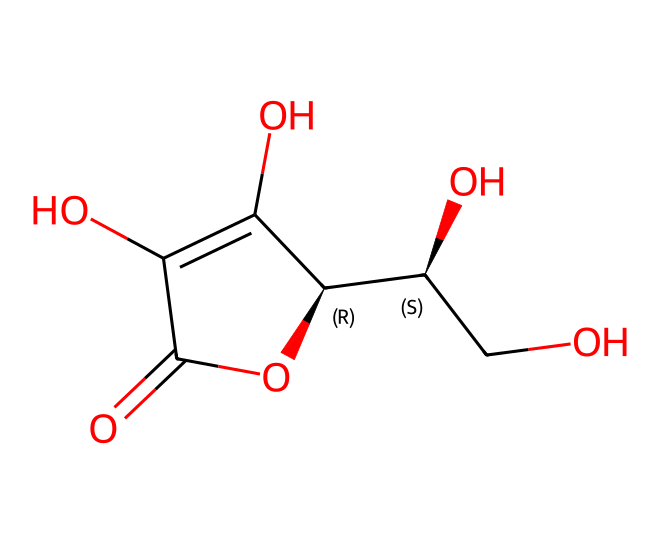What is the molecular formula of this compound? To determine the molecular formula, count the number of each type of atom present in the structure. The structure contains 6 carbon (C) atoms, 8 hydrogen (H) atoms, and 6 oxygen (O) atoms, leading to the formula C6H8O6.
Answer: C6H8O6 How many rings are present in this molecule? By examining the structure, it can be noted that there is one ring formed by the carbon backbone, which is characteristic of cyclic compounds.
Answer: 1 What kind of functional groups can be identified in this antioxidant? Looking at the structure, the characteristic functional groups include hydroxyl (-OH) groups and a carbonyl (C=O) group that indicate alcohol and ketone characteristics.
Answer: hydroxyl, carbonyl How many stereocenters does this molecule have? To find stereocenters, look for carbon atoms bonded to four different substituents. In this structure, there are two stereocenters present.
Answer: 2 Is this molecule soluble in water? The presence of multiple hydroxyl groups generally suggests that the compound is polar and thus soluble in water.
Answer: yes What biological role does Vitamin C play in the body? Vitamin C, also known as ascorbic acid, acts primarily as an antioxidant, helping to protect cells from oxidative stress.
Answer: antioxidant Can this molecule prevent oxidative damage? Yes, due to its ability to donate electrons, this molecule can neutralize free radicals, thus protecting cells from oxidative damage.
Answer: yes 